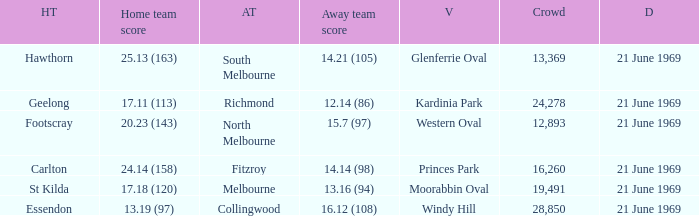What is Essendon's home team that has an away crowd size larger than 19,491? Collingwood. 